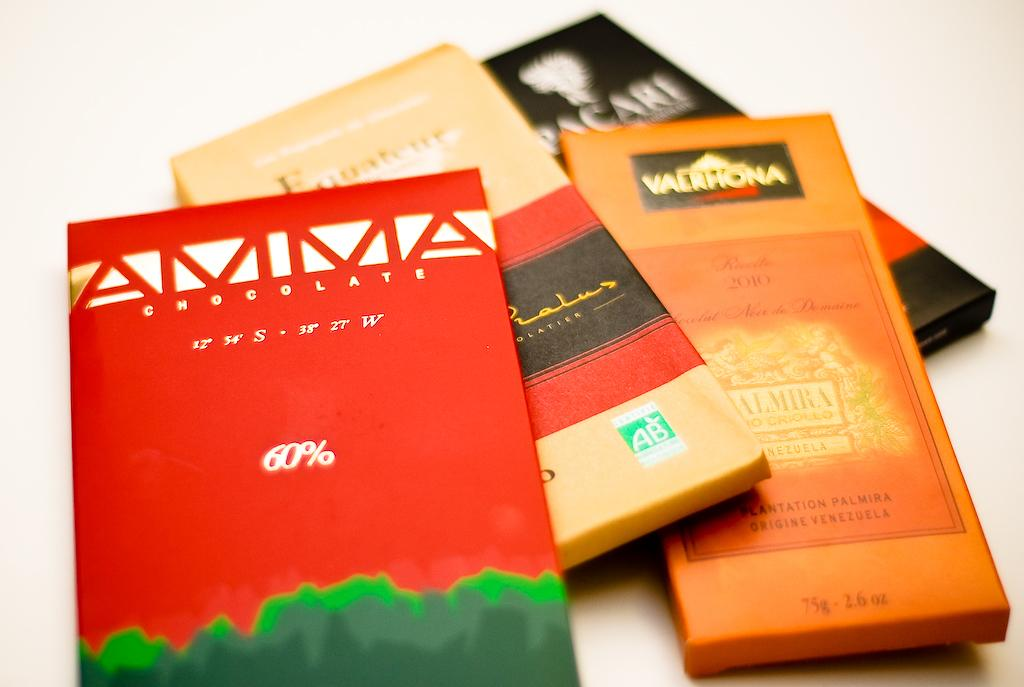<image>
Relay a brief, clear account of the picture shown. Four bars of chocolate are shown and one is an Amma brand. 